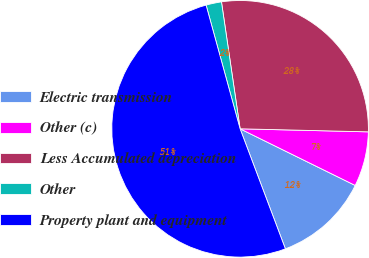Convert chart to OTSL. <chart><loc_0><loc_0><loc_500><loc_500><pie_chart><fcel>Electric transmission<fcel>Other (c)<fcel>Less Accumulated depreciation<fcel>Other<fcel>Property plant and equipment<nl><fcel>11.98%<fcel>6.9%<fcel>27.7%<fcel>1.95%<fcel>51.47%<nl></chart> 